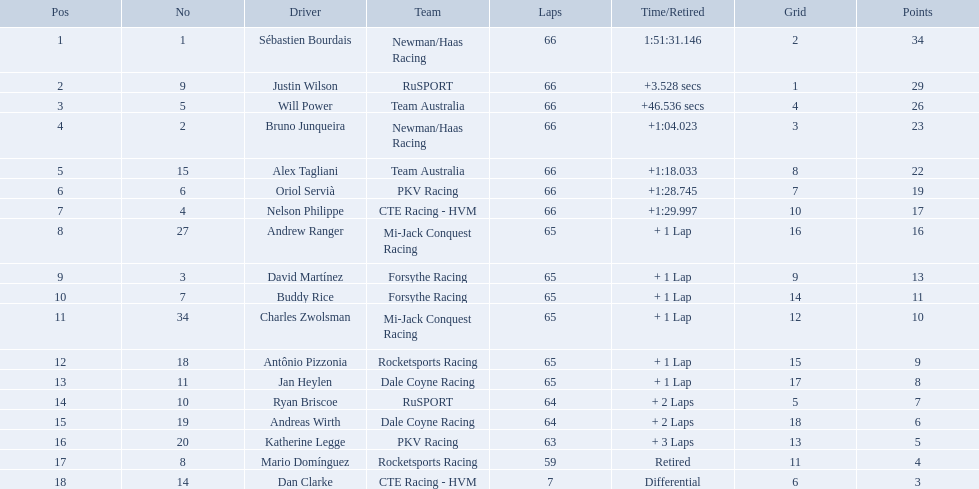How many points did first place receive? 34. How many did last place receive? 3. Who was the recipient of these last place points? Dan Clarke. How many laps did oriol servia complete at the 2006 gran premio? 66. How many laps did katherine legge complete at the 2006 gran premio? 63. Between servia and legge, who completed more laps? Oriol Servià. What was the highest amount of points scored in the 2006 gran premio? 34. Who scored 34 points? Sébastien Bourdais. Which drivers scored at least 10 points? Sébastien Bourdais, Justin Wilson, Will Power, Bruno Junqueira, Alex Tagliani, Oriol Servià, Nelson Philippe, Andrew Ranger, David Martínez, Buddy Rice, Charles Zwolsman. Of those drivers, which ones scored at least 20 points? Sébastien Bourdais, Justin Wilson, Will Power, Bruno Junqueira, Alex Tagliani. Of those 5, which driver scored the most points? Sébastien Bourdais. What are the drivers numbers? 1, 9, 5, 2, 15, 6, 4, 27, 3, 7, 34, 18, 11, 10, 19, 20, 8, 14. Are there any who's number matches his position? Sébastien Bourdais, Oriol Servià. Can you parse all the data within this table? {'header': ['Pos', 'No', 'Driver', 'Team', 'Laps', 'Time/Retired', 'Grid', 'Points'], 'rows': [['1', '1', 'Sébastien Bourdais', 'Newman/Haas Racing', '66', '1:51:31.146', '2', '34'], ['2', '9', 'Justin Wilson', 'RuSPORT', '66', '+3.528 secs', '1', '29'], ['3', '5', 'Will Power', 'Team Australia', '66', '+46.536 secs', '4', '26'], ['4', '2', 'Bruno Junqueira', 'Newman/Haas Racing', '66', '+1:04.023', '3', '23'], ['5', '15', 'Alex Tagliani', 'Team Australia', '66', '+1:18.033', '8', '22'], ['6', '6', 'Oriol Servià', 'PKV Racing', '66', '+1:28.745', '7', '19'], ['7', '4', 'Nelson Philippe', 'CTE Racing - HVM', '66', '+1:29.997', '10', '17'], ['8', '27', 'Andrew Ranger', 'Mi-Jack Conquest Racing', '65', '+ 1 Lap', '16', '16'], ['9', '3', 'David Martínez', 'Forsythe Racing', '65', '+ 1 Lap', '9', '13'], ['10', '7', 'Buddy Rice', 'Forsythe Racing', '65', '+ 1 Lap', '14', '11'], ['11', '34', 'Charles Zwolsman', 'Mi-Jack Conquest Racing', '65', '+ 1 Lap', '12', '10'], ['12', '18', 'Antônio Pizzonia', 'Rocketsports Racing', '65', '+ 1 Lap', '15', '9'], ['13', '11', 'Jan Heylen', 'Dale Coyne Racing', '65', '+ 1 Lap', '17', '8'], ['14', '10', 'Ryan Briscoe', 'RuSPORT', '64', '+ 2 Laps', '5', '7'], ['15', '19', 'Andreas Wirth', 'Dale Coyne Racing', '64', '+ 2 Laps', '18', '6'], ['16', '20', 'Katherine Legge', 'PKV Racing', '63', '+ 3 Laps', '13', '5'], ['17', '8', 'Mario Domínguez', 'Rocketsports Racing', '59', 'Retired', '11', '4'], ['18', '14', 'Dan Clarke', 'CTE Racing - HVM', '7', 'Differential', '6', '3']]} Of those two who has the highest position? Sébastien Bourdais. Who are all the operators? Sébastien Bourdais, Justin Wilson, Will Power, Bruno Junqueira, Alex Tagliani, Oriol Servià, Nelson Philippe, Andrew Ranger, David Martínez, Buddy Rice, Charles Zwolsman, Antônio Pizzonia, Jan Heylen, Ryan Briscoe, Andreas Wirth, Katherine Legge, Mario Domínguez, Dan Clarke. What rank did they attain? 1, 2, 3, 4, 5, 6, 7, 8, 9, 10, 11, 12, 13, 14, 15, 16, 17, 18. Parse the table in full. {'header': ['Pos', 'No', 'Driver', 'Team', 'Laps', 'Time/Retired', 'Grid', 'Points'], 'rows': [['1', '1', 'Sébastien Bourdais', 'Newman/Haas Racing', '66', '1:51:31.146', '2', '34'], ['2', '9', 'Justin Wilson', 'RuSPORT', '66', '+3.528 secs', '1', '29'], ['3', '5', 'Will Power', 'Team Australia', '66', '+46.536 secs', '4', '26'], ['4', '2', 'Bruno Junqueira', 'Newman/Haas Racing', '66', '+1:04.023', '3', '23'], ['5', '15', 'Alex Tagliani', 'Team Australia', '66', '+1:18.033', '8', '22'], ['6', '6', 'Oriol Servià', 'PKV Racing', '66', '+1:28.745', '7', '19'], ['7', '4', 'Nelson Philippe', 'CTE Racing - HVM', '66', '+1:29.997', '10', '17'], ['8', '27', 'Andrew Ranger', 'Mi-Jack Conquest Racing', '65', '+ 1 Lap', '16', '16'], ['9', '3', 'David Martínez', 'Forsythe Racing', '65', '+ 1 Lap', '9', '13'], ['10', '7', 'Buddy Rice', 'Forsythe Racing', '65', '+ 1 Lap', '14', '11'], ['11', '34', 'Charles Zwolsman', 'Mi-Jack Conquest Racing', '65', '+ 1 Lap', '12', '10'], ['12', '18', 'Antônio Pizzonia', 'Rocketsports Racing', '65', '+ 1 Lap', '15', '9'], ['13', '11', 'Jan Heylen', 'Dale Coyne Racing', '65', '+ 1 Lap', '17', '8'], ['14', '10', 'Ryan Briscoe', 'RuSPORT', '64', '+ 2 Laps', '5', '7'], ['15', '19', 'Andreas Wirth', 'Dale Coyne Racing', '64', '+ 2 Laps', '18', '6'], ['16', '20', 'Katherine Legge', 'PKV Racing', '63', '+ 3 Laps', '13', '5'], ['17', '8', 'Mario Domínguez', 'Rocketsports Racing', '59', 'Retired', '11', '4'], ['18', '14', 'Dan Clarke', 'CTE Racing - HVM', '7', 'Differential', '6', '3']]} What is the numeral for each operator? 1, 9, 5, 2, 15, 6, 4, 27, 3, 7, 34, 18, 11, 10, 19, 20, 8, 14. And which participant's numeral and rank correspond? Sébastien Bourdais. How many loops did oriol servia conclude at the 2006 gran premio? 66. How many loops did katherine legge conclude at the 2006 gran premio? 63. Between servia and legge, who concluded more loops? Oriol Servià. Could you help me parse every detail presented in this table? {'header': ['Pos', 'No', 'Driver', 'Team', 'Laps', 'Time/Retired', 'Grid', 'Points'], 'rows': [['1', '1', 'Sébastien Bourdais', 'Newman/Haas Racing', '66', '1:51:31.146', '2', '34'], ['2', '9', 'Justin Wilson', 'RuSPORT', '66', '+3.528 secs', '1', '29'], ['3', '5', 'Will Power', 'Team Australia', '66', '+46.536 secs', '4', '26'], ['4', '2', 'Bruno Junqueira', 'Newman/Haas Racing', '66', '+1:04.023', '3', '23'], ['5', '15', 'Alex Tagliani', 'Team Australia', '66', '+1:18.033', '8', '22'], ['6', '6', 'Oriol Servià', 'PKV Racing', '66', '+1:28.745', '7', '19'], ['7', '4', 'Nelson Philippe', 'CTE Racing - HVM', '66', '+1:29.997', '10', '17'], ['8', '27', 'Andrew Ranger', 'Mi-Jack Conquest Racing', '65', '+ 1 Lap', '16', '16'], ['9', '3', 'David Martínez', 'Forsythe Racing', '65', '+ 1 Lap', '9', '13'], ['10', '7', 'Buddy Rice', 'Forsythe Racing', '65', '+ 1 Lap', '14', '11'], ['11', '34', 'Charles Zwolsman', 'Mi-Jack Conquest Racing', '65', '+ 1 Lap', '12', '10'], ['12', '18', 'Antônio Pizzonia', 'Rocketsports Racing', '65', '+ 1 Lap', '15', '9'], ['13', '11', 'Jan Heylen', 'Dale Coyne Racing', '65', '+ 1 Lap', '17', '8'], ['14', '10', 'Ryan Briscoe', 'RuSPORT', '64', '+ 2 Laps', '5', '7'], ['15', '19', 'Andreas Wirth', 'Dale Coyne Racing', '64', '+ 2 Laps', '18', '6'], ['16', '20', 'Katherine Legge', 'PKV Racing', '63', '+ 3 Laps', '13', '5'], ['17', '8', 'Mario Domínguez', 'Rocketsports Racing', '59', 'Retired', '11', '4'], ['18', '14', 'Dan Clarke', 'CTE Racing - HVM', '7', 'Differential', '6', '3']]} Who are the motorists? Sébastien Bourdais, Justin Wilson, Will Power, Bruno Junqueira, Alex Tagliani, Oriol Servià, Nelson Philippe, Andrew Ranger, David Martínez, Buddy Rice, Charles Zwolsman, Antônio Pizzonia, Jan Heylen, Ryan Briscoe, Andreas Wirth, Katherine Legge, Mario Domínguez, Dan Clarke. What are their figures? 1, 9, 5, 2, 15, 6, 4, 27, 3, 7, 34, 18, 11, 10, 19, 20, 8, 14. What are their locations? 1, 2, 3, 4, 5, 6, 7, 8, 9, 10, 11, 12, 13, 14, 15, 16, 17, 18. Which motorist has the same figure and location? Sébastien Bourdais. Who are all the participants in the 2006 gran premio telmex? Sébastien Bourdais, Justin Wilson, Will Power, Bruno Junqueira, Alex Tagliani, Oriol Servià, Nelson Philippe, Andrew Ranger, David Martínez, Buddy Rice, Charles Zwolsman, Antônio Pizzonia, Jan Heylen, Ryan Briscoe, Andreas Wirth, Katherine Legge, Mario Domínguez, Dan Clarke. How many rounds did they finish? 66, 66, 66, 66, 66, 66, 66, 65, 65, 65, 65, 65, 65, 64, 64, 63, 59, 7. What about just oriol servia and katherine legge? 66, 63. And which of those two participants completed more rounds? Oriol Servià. Which individuals achieved 29+ points? Sébastien Bourdais, Justin Wilson. Who scored more? Sébastien Bourdais. Which drivers accumulated a minimum of 10 points? Sébastien Bourdais, Justin Wilson, Will Power, Bruno Junqueira, Alex Tagliani, Oriol Servià, Nelson Philippe, Andrew Ranger, David Martínez, Buddy Rice, Charles Zwolsman. Of those drivers, which ones gathered at least 20 points? Sébastien Bourdais, Justin Wilson, Will Power, Bruno Junqueira, Alex Tagliani. Of those 5, which driver obtained the highest points? Sébastien Bourdais. What are the names of the competitors who were in spots 14 through 18? Ryan Briscoe, Andreas Wirth, Katherine Legge, Mario Domínguez, Dan Clarke. Of these, which ones didn't conclude due to retirement or differential? Mario Domínguez, Dan Clarke. Which one of the previously mentioned competitors retired? Mario Domínguez. Which of the drivers in question 2 had a differential? Dan Clarke. How many points were awarded to the first position? 34. How many were given to the final position? 3. Who was the receiver of these last position points? Dan Clarke. What was the point total for the winner? 34. How many points did the person in the last position have? 3. Who was the one with the minimum points? Dan Clarke. Which drivers initiated the race from the top 10 spots? Sébastien Bourdais, Justin Wilson, Will Power, Bruno Junqueira, Alex Tagliani, Oriol Servià, Nelson Philippe, Ryan Briscoe, Dan Clarke. From those, who successfully finished all 66 laps? Sébastien Bourdais, Justin Wilson, Will Power, Bruno Junqueira, Alex Tagliani, Oriol Servià, Nelson Philippe. Who were the non-team australia drivers among them? Sébastien Bourdais, Justin Wilson, Bruno Junqueira, Oriol Servià, Nelson Philippe. Who finished with a time gap of more than a minute from the winner? Bruno Junqueira, Oriol Servià, Nelson Philippe. Which driver had the highest car number among these participants? Oriol Servià. At the 2006 gran premio, how many laps did oriol servia finish? 66. How many laps did katherine legge complete? 63. Can you give me this table as a dict? {'header': ['Pos', 'No', 'Driver', 'Team', 'Laps', 'Time/Retired', 'Grid', 'Points'], 'rows': [['1', '1', 'Sébastien Bourdais', 'Newman/Haas Racing', '66', '1:51:31.146', '2', '34'], ['2', '9', 'Justin Wilson', 'RuSPORT', '66', '+3.528 secs', '1', '29'], ['3', '5', 'Will Power', 'Team Australia', '66', '+46.536 secs', '4', '26'], ['4', '2', 'Bruno Junqueira', 'Newman/Haas Racing', '66', '+1:04.023', '3', '23'], ['5', '15', 'Alex Tagliani', 'Team Australia', '66', '+1:18.033', '8', '22'], ['6', '6', 'Oriol Servià', 'PKV Racing', '66', '+1:28.745', '7', '19'], ['7', '4', 'Nelson Philippe', 'CTE Racing - HVM', '66', '+1:29.997', '10', '17'], ['8', '27', 'Andrew Ranger', 'Mi-Jack Conquest Racing', '65', '+ 1 Lap', '16', '16'], ['9', '3', 'David Martínez', 'Forsythe Racing', '65', '+ 1 Lap', '9', '13'], ['10', '7', 'Buddy Rice', 'Forsythe Racing', '65', '+ 1 Lap', '14', '11'], ['11', '34', 'Charles Zwolsman', 'Mi-Jack Conquest Racing', '65', '+ 1 Lap', '12', '10'], ['12', '18', 'Antônio Pizzonia', 'Rocketsports Racing', '65', '+ 1 Lap', '15', '9'], ['13', '11', 'Jan Heylen', 'Dale Coyne Racing', '65', '+ 1 Lap', '17', '8'], ['14', '10', 'Ryan Briscoe', 'RuSPORT', '64', '+ 2 Laps', '5', '7'], ['15', '19', 'Andreas Wirth', 'Dale Coyne Racing', '64', '+ 2 Laps', '18', '6'], ['16', '20', 'Katherine Legge', 'PKV Racing', '63', '+ 3 Laps', '13', '5'], ['17', '8', 'Mario Domínguez', 'Rocketsports Racing', '59', 'Retired', '11', '4'], ['18', '14', 'Dan Clarke', 'CTE Racing - HVM', '7', 'Differential', '6', '3']]} Who had more laps completed between the two? Oriol Servià. Who are the individuals who achieved more than 29 points? Sébastien Bourdais, Justin Wilson. Who had a higher score? Sébastien Bourdais. Who managed to score over 29 points? Sébastien Bourdais, Justin Wilson. Who had a greater score? Sébastien Bourdais. What are the numbers of the drivers? 1, 9, 5, 2, 15, 6, 4, 27, 3, 7, 34, 18, 11, 10, 19, 20, 8, 14. Are there any drivers with a number corresponding to their position? Sébastien Bourdais, Oriol Servià. Among those, who holds the highest position? Sébastien Bourdais. 